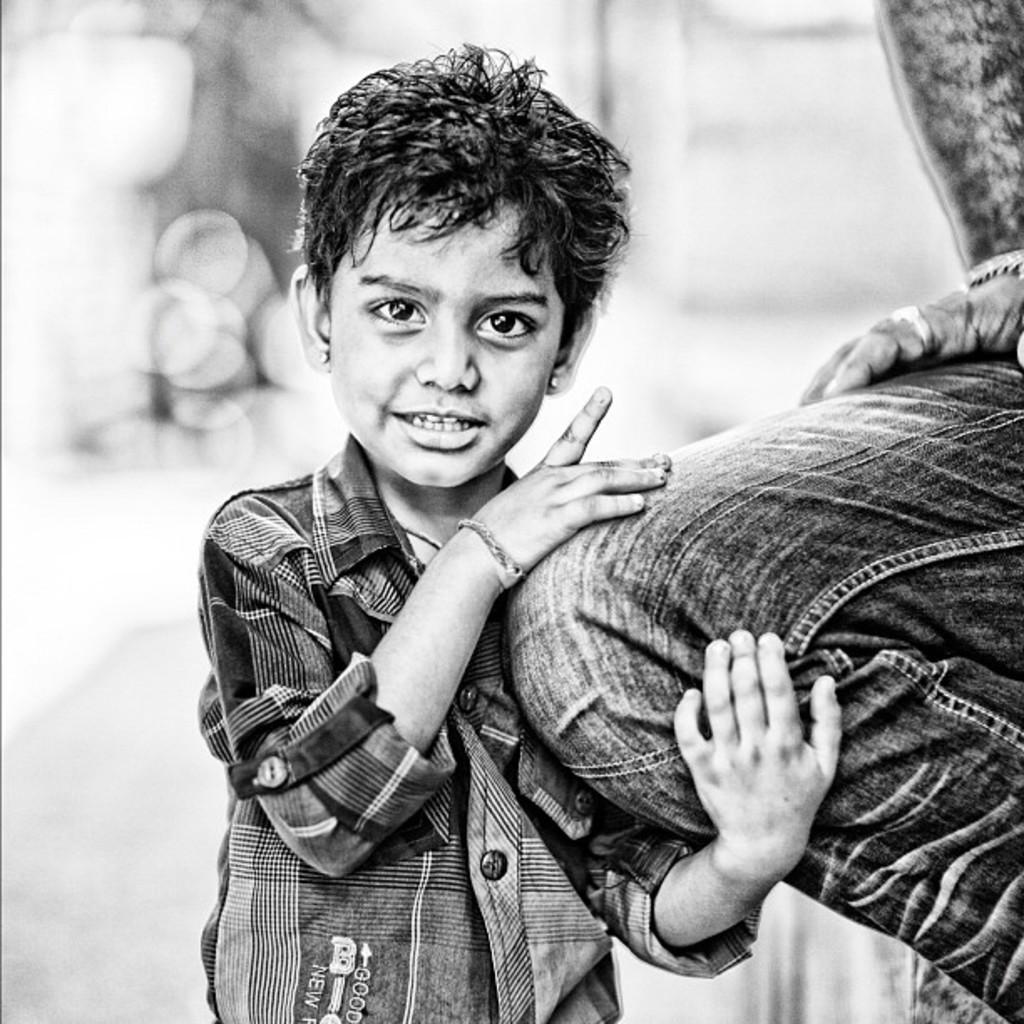How would you summarize this image in a sentence or two? In this picture I can see a boy and a human on the right side. I can see blurry background and it is a black and white image. 